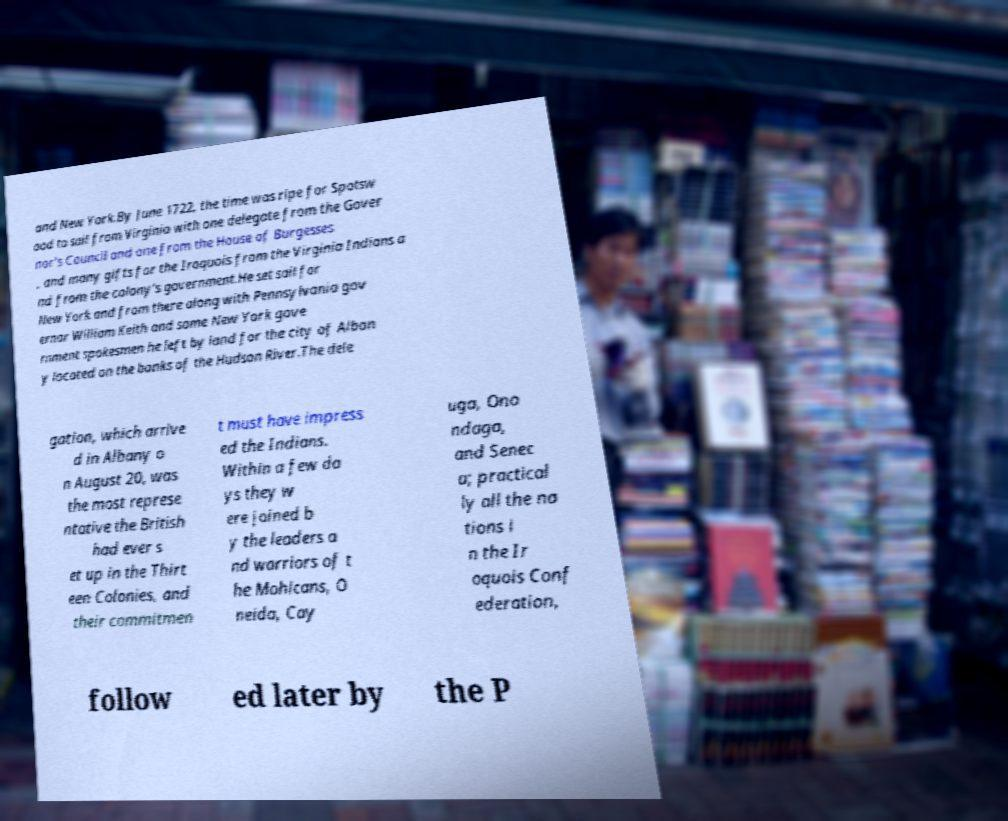Please identify and transcribe the text found in this image. and New York.By June 1722, the time was ripe for Spotsw ood to sail from Virginia with one delegate from the Gover nor's Council and one from the House of Burgesses , and many gifts for the Iroquois from the Virginia Indians a nd from the colony's government.He set sail for New York and from there along with Pennsylvania gov ernor William Keith and some New York gove rnment spokesmen he left by land for the city of Alban y located on the banks of the Hudson River.The dele gation, which arrive d in Albany o n August 20, was the most represe ntative the British had ever s et up in the Thirt een Colonies, and their commitmen t must have impress ed the Indians. Within a few da ys they w ere joined b y the leaders a nd warriors of t he Mohicans, O neida, Cay uga, Ono ndaga, and Senec a; practical ly all the na tions i n the Ir oquois Conf ederation, follow ed later by the P 